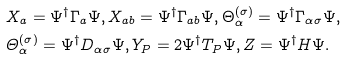Convert formula to latex. <formula><loc_0><loc_0><loc_500><loc_500>& X _ { a } = \Psi ^ { \dagger } \Gamma _ { a } \Psi , X _ { a b } = \Psi ^ { \dagger } \Gamma _ { a b } \Psi , \Theta _ { \alpha } ^ { ( \sigma ) } = \Psi ^ { \dagger } \Gamma _ { \alpha \sigma } \Psi , \\ & \varTheta _ { \alpha } ^ { ( \sigma ) } = \Psi ^ { \dagger } D _ { \alpha \sigma } \Psi , Y _ { P } = 2 \Psi ^ { \dagger } T _ { P } \Psi , Z = \Psi ^ { \dagger } H \Psi .</formula> 